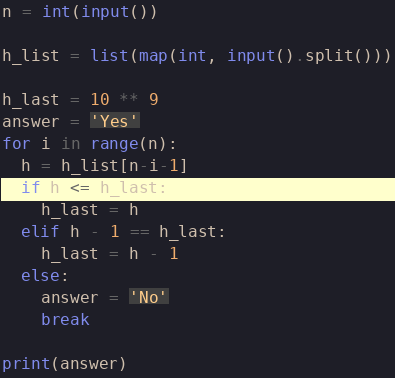Convert code to text. <code><loc_0><loc_0><loc_500><loc_500><_Python_>n = int(input())

h_list = list(map(int, input().split()))

h_last = 10 ** 9
answer = 'Yes'
for i in range(n):
  h = h_list[n-i-1]
  if h <= h_last:
    h_last = h
  elif h - 1 == h_last:
    h_last = h - 1
  else:
    answer = 'No'
    break

print(answer)</code> 